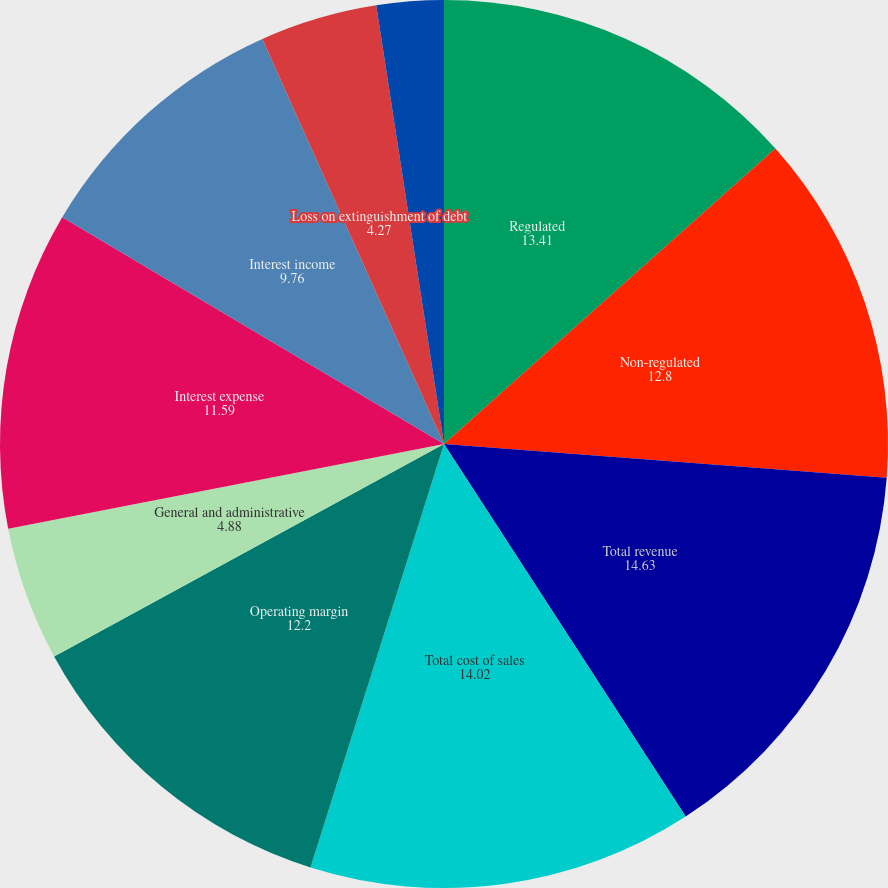Convert chart. <chart><loc_0><loc_0><loc_500><loc_500><pie_chart><fcel>Regulated<fcel>Non-regulated<fcel>Total revenue<fcel>Total cost of sales<fcel>Operating margin<fcel>General and administrative<fcel>Interest expense<fcel>Interest income<fcel>Loss on extinguishment of debt<fcel>Other expense<nl><fcel>13.41%<fcel>12.8%<fcel>14.63%<fcel>14.02%<fcel>12.2%<fcel>4.88%<fcel>11.59%<fcel>9.76%<fcel>4.27%<fcel>2.44%<nl></chart> 